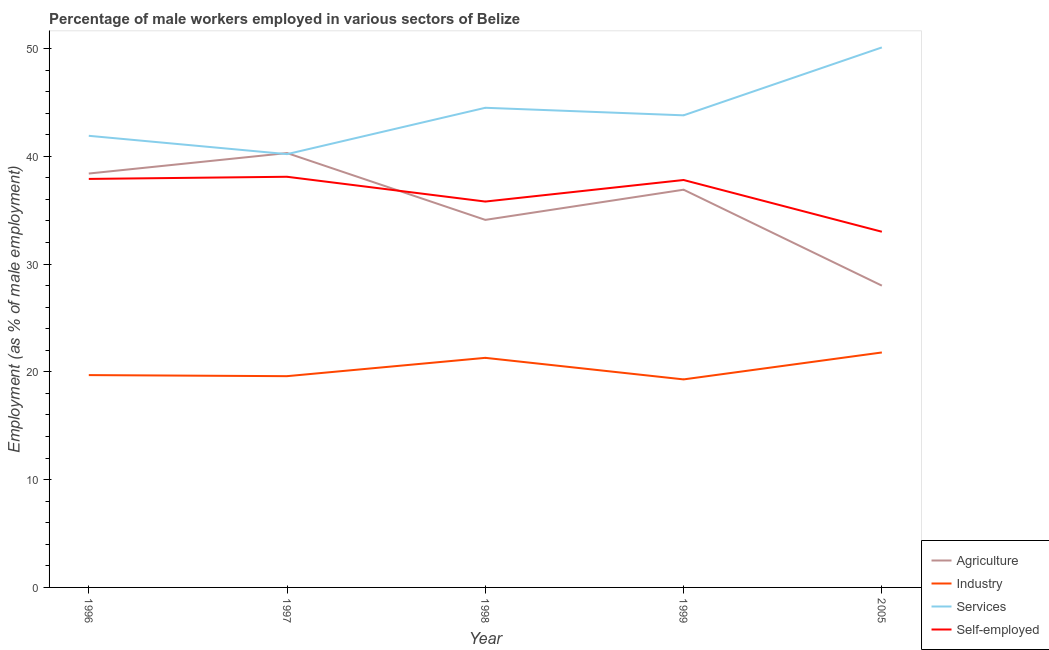How many different coloured lines are there?
Make the answer very short. 4. What is the percentage of male workers in industry in 1998?
Keep it short and to the point. 21.3. Across all years, what is the maximum percentage of male workers in agriculture?
Your answer should be compact. 40.3. Across all years, what is the minimum percentage of male workers in industry?
Provide a succinct answer. 19.3. In which year was the percentage of self employed male workers minimum?
Offer a terse response. 2005. What is the total percentage of male workers in services in the graph?
Your answer should be compact. 220.5. What is the difference between the percentage of male workers in services in 1997 and that in 2005?
Give a very brief answer. -9.9. What is the difference between the percentage of male workers in services in 1998 and the percentage of self employed male workers in 2005?
Give a very brief answer. 11.5. What is the average percentage of male workers in agriculture per year?
Ensure brevity in your answer.  35.54. In the year 2005, what is the difference between the percentage of male workers in services and percentage of male workers in industry?
Make the answer very short. 28.3. In how many years, is the percentage of male workers in services greater than 12 %?
Make the answer very short. 5. What is the ratio of the percentage of male workers in industry in 1999 to that in 2005?
Keep it short and to the point. 0.89. Is the percentage of male workers in industry in 1996 less than that in 1999?
Your answer should be very brief. No. What is the difference between the highest and the lowest percentage of male workers in services?
Provide a succinct answer. 9.9. In how many years, is the percentage of male workers in agriculture greater than the average percentage of male workers in agriculture taken over all years?
Provide a short and direct response. 3. Is the sum of the percentage of self employed male workers in 1998 and 1999 greater than the maximum percentage of male workers in agriculture across all years?
Your answer should be compact. Yes. Is it the case that in every year, the sum of the percentage of male workers in agriculture and percentage of male workers in industry is greater than the percentage of male workers in services?
Your response must be concise. No. Is the percentage of self employed male workers strictly greater than the percentage of male workers in services over the years?
Provide a short and direct response. No. Is the percentage of male workers in industry strictly less than the percentage of male workers in agriculture over the years?
Provide a short and direct response. Yes. What is the difference between two consecutive major ticks on the Y-axis?
Offer a very short reply. 10. Are the values on the major ticks of Y-axis written in scientific E-notation?
Ensure brevity in your answer.  No. Does the graph contain grids?
Your response must be concise. No. What is the title of the graph?
Your response must be concise. Percentage of male workers employed in various sectors of Belize. What is the label or title of the X-axis?
Provide a short and direct response. Year. What is the label or title of the Y-axis?
Offer a very short reply. Employment (as % of male employment). What is the Employment (as % of male employment) of Agriculture in 1996?
Your answer should be compact. 38.4. What is the Employment (as % of male employment) in Industry in 1996?
Your response must be concise. 19.7. What is the Employment (as % of male employment) in Services in 1996?
Your answer should be very brief. 41.9. What is the Employment (as % of male employment) of Self-employed in 1996?
Your answer should be compact. 37.9. What is the Employment (as % of male employment) of Agriculture in 1997?
Give a very brief answer. 40.3. What is the Employment (as % of male employment) of Industry in 1997?
Provide a short and direct response. 19.6. What is the Employment (as % of male employment) of Services in 1997?
Provide a succinct answer. 40.2. What is the Employment (as % of male employment) in Self-employed in 1997?
Your response must be concise. 38.1. What is the Employment (as % of male employment) of Agriculture in 1998?
Provide a succinct answer. 34.1. What is the Employment (as % of male employment) of Industry in 1998?
Your answer should be compact. 21.3. What is the Employment (as % of male employment) in Services in 1998?
Ensure brevity in your answer.  44.5. What is the Employment (as % of male employment) of Self-employed in 1998?
Give a very brief answer. 35.8. What is the Employment (as % of male employment) of Agriculture in 1999?
Your answer should be compact. 36.9. What is the Employment (as % of male employment) in Industry in 1999?
Your answer should be compact. 19.3. What is the Employment (as % of male employment) in Services in 1999?
Offer a very short reply. 43.8. What is the Employment (as % of male employment) in Self-employed in 1999?
Offer a very short reply. 37.8. What is the Employment (as % of male employment) of Agriculture in 2005?
Keep it short and to the point. 28. What is the Employment (as % of male employment) in Industry in 2005?
Your answer should be very brief. 21.8. What is the Employment (as % of male employment) of Services in 2005?
Provide a succinct answer. 50.1. Across all years, what is the maximum Employment (as % of male employment) in Agriculture?
Give a very brief answer. 40.3. Across all years, what is the maximum Employment (as % of male employment) of Industry?
Provide a succinct answer. 21.8. Across all years, what is the maximum Employment (as % of male employment) in Services?
Your answer should be very brief. 50.1. Across all years, what is the maximum Employment (as % of male employment) in Self-employed?
Your answer should be very brief. 38.1. Across all years, what is the minimum Employment (as % of male employment) in Industry?
Your answer should be very brief. 19.3. Across all years, what is the minimum Employment (as % of male employment) in Services?
Keep it short and to the point. 40.2. What is the total Employment (as % of male employment) in Agriculture in the graph?
Give a very brief answer. 177.7. What is the total Employment (as % of male employment) in Industry in the graph?
Give a very brief answer. 101.7. What is the total Employment (as % of male employment) of Services in the graph?
Offer a very short reply. 220.5. What is the total Employment (as % of male employment) in Self-employed in the graph?
Give a very brief answer. 182.6. What is the difference between the Employment (as % of male employment) of Industry in 1996 and that in 1998?
Give a very brief answer. -1.6. What is the difference between the Employment (as % of male employment) in Self-employed in 1996 and that in 1998?
Offer a very short reply. 2.1. What is the difference between the Employment (as % of male employment) in Agriculture in 1996 and that in 1999?
Offer a very short reply. 1.5. What is the difference between the Employment (as % of male employment) in Industry in 1996 and that in 1999?
Your answer should be very brief. 0.4. What is the difference between the Employment (as % of male employment) in Self-employed in 1996 and that in 1999?
Keep it short and to the point. 0.1. What is the difference between the Employment (as % of male employment) in Services in 1996 and that in 2005?
Your answer should be very brief. -8.2. What is the difference between the Employment (as % of male employment) of Self-employed in 1996 and that in 2005?
Provide a short and direct response. 4.9. What is the difference between the Employment (as % of male employment) in Agriculture in 1997 and that in 1998?
Your response must be concise. 6.2. What is the difference between the Employment (as % of male employment) in Agriculture in 1997 and that in 1999?
Offer a very short reply. 3.4. What is the difference between the Employment (as % of male employment) in Industry in 1997 and that in 1999?
Offer a very short reply. 0.3. What is the difference between the Employment (as % of male employment) of Services in 1997 and that in 1999?
Your response must be concise. -3.6. What is the difference between the Employment (as % of male employment) of Services in 1997 and that in 2005?
Offer a terse response. -9.9. What is the difference between the Employment (as % of male employment) of Self-employed in 1997 and that in 2005?
Offer a very short reply. 5.1. What is the difference between the Employment (as % of male employment) of Agriculture in 1998 and that in 1999?
Offer a terse response. -2.8. What is the difference between the Employment (as % of male employment) of Industry in 1998 and that in 1999?
Provide a short and direct response. 2. What is the difference between the Employment (as % of male employment) in Services in 1998 and that in 1999?
Your answer should be compact. 0.7. What is the difference between the Employment (as % of male employment) in Agriculture in 1998 and that in 2005?
Your answer should be very brief. 6.1. What is the difference between the Employment (as % of male employment) of Services in 1999 and that in 2005?
Provide a succinct answer. -6.3. What is the difference between the Employment (as % of male employment) in Self-employed in 1999 and that in 2005?
Give a very brief answer. 4.8. What is the difference between the Employment (as % of male employment) of Agriculture in 1996 and the Employment (as % of male employment) of Services in 1997?
Offer a terse response. -1.8. What is the difference between the Employment (as % of male employment) of Agriculture in 1996 and the Employment (as % of male employment) of Self-employed in 1997?
Provide a succinct answer. 0.3. What is the difference between the Employment (as % of male employment) in Industry in 1996 and the Employment (as % of male employment) in Services in 1997?
Ensure brevity in your answer.  -20.5. What is the difference between the Employment (as % of male employment) in Industry in 1996 and the Employment (as % of male employment) in Self-employed in 1997?
Offer a very short reply. -18.4. What is the difference between the Employment (as % of male employment) of Industry in 1996 and the Employment (as % of male employment) of Services in 1998?
Provide a succinct answer. -24.8. What is the difference between the Employment (as % of male employment) in Industry in 1996 and the Employment (as % of male employment) in Self-employed in 1998?
Ensure brevity in your answer.  -16.1. What is the difference between the Employment (as % of male employment) in Agriculture in 1996 and the Employment (as % of male employment) in Services in 1999?
Make the answer very short. -5.4. What is the difference between the Employment (as % of male employment) in Agriculture in 1996 and the Employment (as % of male employment) in Self-employed in 1999?
Ensure brevity in your answer.  0.6. What is the difference between the Employment (as % of male employment) in Industry in 1996 and the Employment (as % of male employment) in Services in 1999?
Offer a terse response. -24.1. What is the difference between the Employment (as % of male employment) of Industry in 1996 and the Employment (as % of male employment) of Self-employed in 1999?
Offer a terse response. -18.1. What is the difference between the Employment (as % of male employment) in Services in 1996 and the Employment (as % of male employment) in Self-employed in 1999?
Make the answer very short. 4.1. What is the difference between the Employment (as % of male employment) of Agriculture in 1996 and the Employment (as % of male employment) of Services in 2005?
Give a very brief answer. -11.7. What is the difference between the Employment (as % of male employment) in Agriculture in 1996 and the Employment (as % of male employment) in Self-employed in 2005?
Offer a very short reply. 5.4. What is the difference between the Employment (as % of male employment) in Industry in 1996 and the Employment (as % of male employment) in Services in 2005?
Your answer should be very brief. -30.4. What is the difference between the Employment (as % of male employment) of Industry in 1996 and the Employment (as % of male employment) of Self-employed in 2005?
Your response must be concise. -13.3. What is the difference between the Employment (as % of male employment) in Agriculture in 1997 and the Employment (as % of male employment) in Self-employed in 1998?
Provide a succinct answer. 4.5. What is the difference between the Employment (as % of male employment) in Industry in 1997 and the Employment (as % of male employment) in Services in 1998?
Make the answer very short. -24.9. What is the difference between the Employment (as % of male employment) in Industry in 1997 and the Employment (as % of male employment) in Self-employed in 1998?
Make the answer very short. -16.2. What is the difference between the Employment (as % of male employment) of Services in 1997 and the Employment (as % of male employment) of Self-employed in 1998?
Provide a succinct answer. 4.4. What is the difference between the Employment (as % of male employment) of Agriculture in 1997 and the Employment (as % of male employment) of Industry in 1999?
Your response must be concise. 21. What is the difference between the Employment (as % of male employment) in Agriculture in 1997 and the Employment (as % of male employment) in Services in 1999?
Provide a short and direct response. -3.5. What is the difference between the Employment (as % of male employment) of Industry in 1997 and the Employment (as % of male employment) of Services in 1999?
Make the answer very short. -24.2. What is the difference between the Employment (as % of male employment) of Industry in 1997 and the Employment (as % of male employment) of Self-employed in 1999?
Offer a very short reply. -18.2. What is the difference between the Employment (as % of male employment) in Agriculture in 1997 and the Employment (as % of male employment) in Industry in 2005?
Provide a short and direct response. 18.5. What is the difference between the Employment (as % of male employment) of Agriculture in 1997 and the Employment (as % of male employment) of Self-employed in 2005?
Your answer should be very brief. 7.3. What is the difference between the Employment (as % of male employment) in Industry in 1997 and the Employment (as % of male employment) in Services in 2005?
Your answer should be very brief. -30.5. What is the difference between the Employment (as % of male employment) of Services in 1997 and the Employment (as % of male employment) of Self-employed in 2005?
Provide a succinct answer. 7.2. What is the difference between the Employment (as % of male employment) in Agriculture in 1998 and the Employment (as % of male employment) in Industry in 1999?
Offer a very short reply. 14.8. What is the difference between the Employment (as % of male employment) of Agriculture in 1998 and the Employment (as % of male employment) of Services in 1999?
Give a very brief answer. -9.7. What is the difference between the Employment (as % of male employment) of Agriculture in 1998 and the Employment (as % of male employment) of Self-employed in 1999?
Ensure brevity in your answer.  -3.7. What is the difference between the Employment (as % of male employment) in Industry in 1998 and the Employment (as % of male employment) in Services in 1999?
Provide a succinct answer. -22.5. What is the difference between the Employment (as % of male employment) in Industry in 1998 and the Employment (as % of male employment) in Self-employed in 1999?
Make the answer very short. -16.5. What is the difference between the Employment (as % of male employment) of Services in 1998 and the Employment (as % of male employment) of Self-employed in 1999?
Provide a short and direct response. 6.7. What is the difference between the Employment (as % of male employment) in Agriculture in 1998 and the Employment (as % of male employment) in Self-employed in 2005?
Make the answer very short. 1.1. What is the difference between the Employment (as % of male employment) in Industry in 1998 and the Employment (as % of male employment) in Services in 2005?
Provide a short and direct response. -28.8. What is the difference between the Employment (as % of male employment) in Services in 1998 and the Employment (as % of male employment) in Self-employed in 2005?
Your response must be concise. 11.5. What is the difference between the Employment (as % of male employment) of Agriculture in 1999 and the Employment (as % of male employment) of Industry in 2005?
Give a very brief answer. 15.1. What is the difference between the Employment (as % of male employment) of Industry in 1999 and the Employment (as % of male employment) of Services in 2005?
Make the answer very short. -30.8. What is the difference between the Employment (as % of male employment) in Industry in 1999 and the Employment (as % of male employment) in Self-employed in 2005?
Keep it short and to the point. -13.7. What is the difference between the Employment (as % of male employment) in Services in 1999 and the Employment (as % of male employment) in Self-employed in 2005?
Give a very brief answer. 10.8. What is the average Employment (as % of male employment) in Agriculture per year?
Your answer should be compact. 35.54. What is the average Employment (as % of male employment) of Industry per year?
Provide a short and direct response. 20.34. What is the average Employment (as % of male employment) of Services per year?
Make the answer very short. 44.1. What is the average Employment (as % of male employment) of Self-employed per year?
Your response must be concise. 36.52. In the year 1996, what is the difference between the Employment (as % of male employment) in Agriculture and Employment (as % of male employment) in Industry?
Ensure brevity in your answer.  18.7. In the year 1996, what is the difference between the Employment (as % of male employment) in Agriculture and Employment (as % of male employment) in Services?
Provide a short and direct response. -3.5. In the year 1996, what is the difference between the Employment (as % of male employment) of Industry and Employment (as % of male employment) of Services?
Your response must be concise. -22.2. In the year 1996, what is the difference between the Employment (as % of male employment) of Industry and Employment (as % of male employment) of Self-employed?
Your response must be concise. -18.2. In the year 1997, what is the difference between the Employment (as % of male employment) of Agriculture and Employment (as % of male employment) of Industry?
Your answer should be very brief. 20.7. In the year 1997, what is the difference between the Employment (as % of male employment) of Agriculture and Employment (as % of male employment) of Services?
Give a very brief answer. 0.1. In the year 1997, what is the difference between the Employment (as % of male employment) in Agriculture and Employment (as % of male employment) in Self-employed?
Give a very brief answer. 2.2. In the year 1997, what is the difference between the Employment (as % of male employment) in Industry and Employment (as % of male employment) in Services?
Offer a terse response. -20.6. In the year 1997, what is the difference between the Employment (as % of male employment) in Industry and Employment (as % of male employment) in Self-employed?
Give a very brief answer. -18.5. In the year 1998, what is the difference between the Employment (as % of male employment) in Agriculture and Employment (as % of male employment) in Industry?
Provide a short and direct response. 12.8. In the year 1998, what is the difference between the Employment (as % of male employment) in Agriculture and Employment (as % of male employment) in Self-employed?
Your answer should be compact. -1.7. In the year 1998, what is the difference between the Employment (as % of male employment) in Industry and Employment (as % of male employment) in Services?
Provide a short and direct response. -23.2. In the year 1998, what is the difference between the Employment (as % of male employment) of Services and Employment (as % of male employment) of Self-employed?
Ensure brevity in your answer.  8.7. In the year 1999, what is the difference between the Employment (as % of male employment) of Agriculture and Employment (as % of male employment) of Self-employed?
Provide a succinct answer. -0.9. In the year 1999, what is the difference between the Employment (as % of male employment) in Industry and Employment (as % of male employment) in Services?
Provide a short and direct response. -24.5. In the year 1999, what is the difference between the Employment (as % of male employment) of Industry and Employment (as % of male employment) of Self-employed?
Provide a succinct answer. -18.5. In the year 1999, what is the difference between the Employment (as % of male employment) of Services and Employment (as % of male employment) of Self-employed?
Your answer should be very brief. 6. In the year 2005, what is the difference between the Employment (as % of male employment) of Agriculture and Employment (as % of male employment) of Industry?
Keep it short and to the point. 6.2. In the year 2005, what is the difference between the Employment (as % of male employment) in Agriculture and Employment (as % of male employment) in Services?
Make the answer very short. -22.1. In the year 2005, what is the difference between the Employment (as % of male employment) in Agriculture and Employment (as % of male employment) in Self-employed?
Make the answer very short. -5. In the year 2005, what is the difference between the Employment (as % of male employment) of Industry and Employment (as % of male employment) of Services?
Ensure brevity in your answer.  -28.3. What is the ratio of the Employment (as % of male employment) of Agriculture in 1996 to that in 1997?
Your answer should be compact. 0.95. What is the ratio of the Employment (as % of male employment) in Services in 1996 to that in 1997?
Provide a short and direct response. 1.04. What is the ratio of the Employment (as % of male employment) of Self-employed in 1996 to that in 1997?
Your answer should be compact. 0.99. What is the ratio of the Employment (as % of male employment) of Agriculture in 1996 to that in 1998?
Your answer should be very brief. 1.13. What is the ratio of the Employment (as % of male employment) of Industry in 1996 to that in 1998?
Provide a short and direct response. 0.92. What is the ratio of the Employment (as % of male employment) in Services in 1996 to that in 1998?
Ensure brevity in your answer.  0.94. What is the ratio of the Employment (as % of male employment) in Self-employed in 1996 to that in 1998?
Keep it short and to the point. 1.06. What is the ratio of the Employment (as % of male employment) of Agriculture in 1996 to that in 1999?
Your answer should be compact. 1.04. What is the ratio of the Employment (as % of male employment) in Industry in 1996 to that in 1999?
Provide a short and direct response. 1.02. What is the ratio of the Employment (as % of male employment) of Services in 1996 to that in 1999?
Keep it short and to the point. 0.96. What is the ratio of the Employment (as % of male employment) in Agriculture in 1996 to that in 2005?
Make the answer very short. 1.37. What is the ratio of the Employment (as % of male employment) in Industry in 1996 to that in 2005?
Offer a very short reply. 0.9. What is the ratio of the Employment (as % of male employment) in Services in 1996 to that in 2005?
Provide a succinct answer. 0.84. What is the ratio of the Employment (as % of male employment) in Self-employed in 1996 to that in 2005?
Provide a succinct answer. 1.15. What is the ratio of the Employment (as % of male employment) of Agriculture in 1997 to that in 1998?
Make the answer very short. 1.18. What is the ratio of the Employment (as % of male employment) in Industry in 1997 to that in 1998?
Keep it short and to the point. 0.92. What is the ratio of the Employment (as % of male employment) of Services in 1997 to that in 1998?
Make the answer very short. 0.9. What is the ratio of the Employment (as % of male employment) in Self-employed in 1997 to that in 1998?
Keep it short and to the point. 1.06. What is the ratio of the Employment (as % of male employment) in Agriculture in 1997 to that in 1999?
Provide a short and direct response. 1.09. What is the ratio of the Employment (as % of male employment) in Industry in 1997 to that in 1999?
Your response must be concise. 1.02. What is the ratio of the Employment (as % of male employment) in Services in 1997 to that in 1999?
Provide a short and direct response. 0.92. What is the ratio of the Employment (as % of male employment) in Self-employed in 1997 to that in 1999?
Your response must be concise. 1.01. What is the ratio of the Employment (as % of male employment) of Agriculture in 1997 to that in 2005?
Give a very brief answer. 1.44. What is the ratio of the Employment (as % of male employment) of Industry in 1997 to that in 2005?
Provide a succinct answer. 0.9. What is the ratio of the Employment (as % of male employment) in Services in 1997 to that in 2005?
Your answer should be compact. 0.8. What is the ratio of the Employment (as % of male employment) in Self-employed in 1997 to that in 2005?
Offer a terse response. 1.15. What is the ratio of the Employment (as % of male employment) in Agriculture in 1998 to that in 1999?
Keep it short and to the point. 0.92. What is the ratio of the Employment (as % of male employment) in Industry in 1998 to that in 1999?
Make the answer very short. 1.1. What is the ratio of the Employment (as % of male employment) of Services in 1998 to that in 1999?
Your answer should be very brief. 1.02. What is the ratio of the Employment (as % of male employment) in Self-employed in 1998 to that in 1999?
Offer a terse response. 0.95. What is the ratio of the Employment (as % of male employment) of Agriculture in 1998 to that in 2005?
Your answer should be compact. 1.22. What is the ratio of the Employment (as % of male employment) of Industry in 1998 to that in 2005?
Make the answer very short. 0.98. What is the ratio of the Employment (as % of male employment) of Services in 1998 to that in 2005?
Provide a short and direct response. 0.89. What is the ratio of the Employment (as % of male employment) of Self-employed in 1998 to that in 2005?
Offer a terse response. 1.08. What is the ratio of the Employment (as % of male employment) in Agriculture in 1999 to that in 2005?
Your response must be concise. 1.32. What is the ratio of the Employment (as % of male employment) of Industry in 1999 to that in 2005?
Ensure brevity in your answer.  0.89. What is the ratio of the Employment (as % of male employment) of Services in 1999 to that in 2005?
Your answer should be very brief. 0.87. What is the ratio of the Employment (as % of male employment) of Self-employed in 1999 to that in 2005?
Provide a short and direct response. 1.15. What is the difference between the highest and the second highest Employment (as % of male employment) of Agriculture?
Ensure brevity in your answer.  1.9. What is the difference between the highest and the second highest Employment (as % of male employment) of Services?
Keep it short and to the point. 5.6. What is the difference between the highest and the lowest Employment (as % of male employment) in Agriculture?
Offer a terse response. 12.3. What is the difference between the highest and the lowest Employment (as % of male employment) in Industry?
Your answer should be compact. 2.5. 